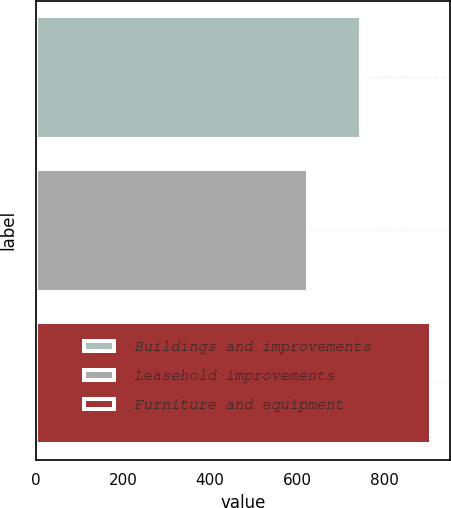Convert chart. <chart><loc_0><loc_0><loc_500><loc_500><bar_chart><fcel>Buildings and improvements<fcel>Leasehold improvements<fcel>Furniture and equipment<nl><fcel>747<fcel>626<fcel>907<nl></chart> 